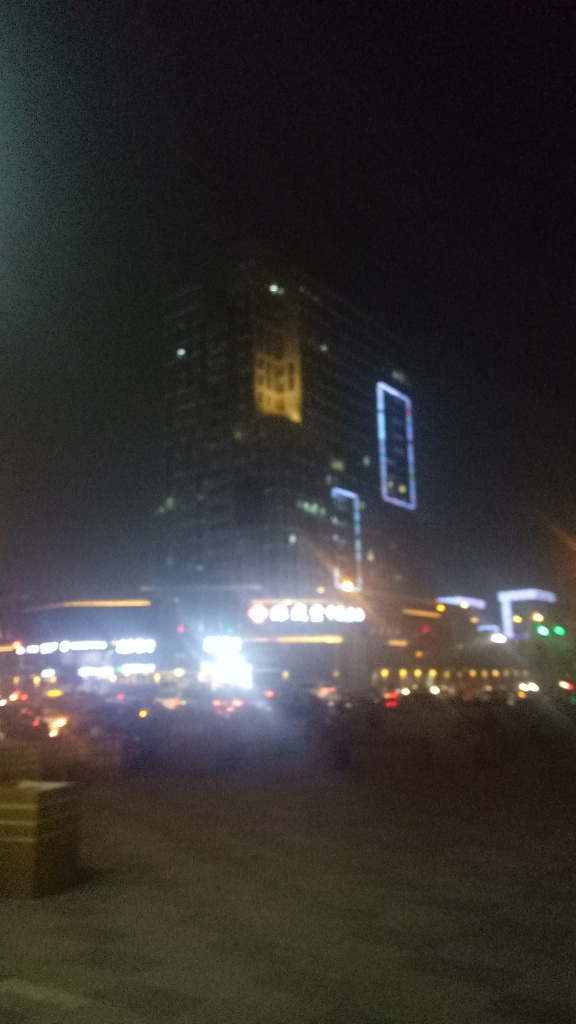What is the overall quality of this image?
A. Good
B. Very poor
C. Average
D. Excellent The overall quality of the image is 'very poor' due to several factors. To begin with, the image is blurry, which obscures details and makes it difficult to identify specific features. The lighting in the image is also inadequate, with some areas being overexposed while others are shrouded in darkness. This uneven lighting limits the visibility of the scene. Additionally, the image's composition seems to lack a focal point, making it less engaging for the viewer. 